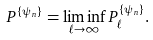Convert formula to latex. <formula><loc_0><loc_0><loc_500><loc_500>P ^ { \{ \psi _ { n } \} } = \liminf _ { \ell \rightarrow \infty } P ^ { \{ \psi _ { n } \} } _ { \ell } .</formula> 